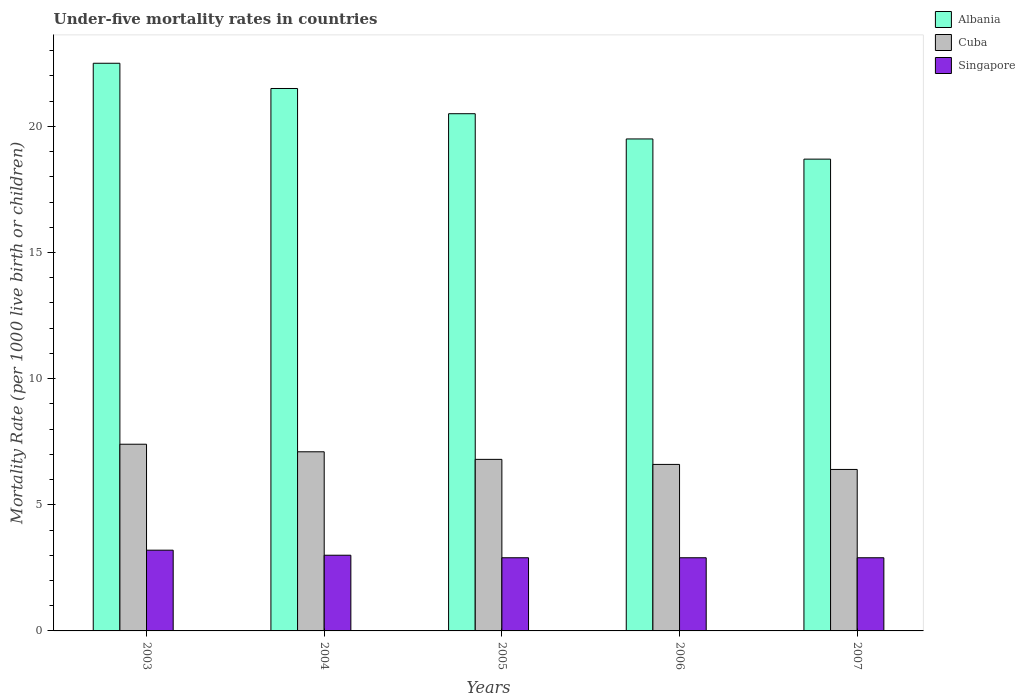How many groups of bars are there?
Your answer should be very brief. 5. Are the number of bars on each tick of the X-axis equal?
Provide a succinct answer. Yes. Across all years, what is the minimum under-five mortality rate in Singapore?
Offer a terse response. 2.9. In which year was the under-five mortality rate in Singapore maximum?
Your response must be concise. 2003. What is the total under-five mortality rate in Cuba in the graph?
Give a very brief answer. 34.3. What is the difference between the under-five mortality rate in Albania in 2003 and that in 2006?
Your answer should be very brief. 3. What is the difference between the under-five mortality rate in Singapore in 2007 and the under-five mortality rate in Albania in 2003?
Give a very brief answer. -19.6. What is the average under-five mortality rate in Cuba per year?
Offer a terse response. 6.86. In the year 2006, what is the difference between the under-five mortality rate in Singapore and under-five mortality rate in Albania?
Your response must be concise. -16.6. What is the ratio of the under-five mortality rate in Cuba in 2005 to that in 2006?
Provide a short and direct response. 1.03. Is the under-five mortality rate in Albania in 2003 less than that in 2006?
Keep it short and to the point. No. What is the difference between the highest and the second highest under-five mortality rate in Albania?
Keep it short and to the point. 1. What is the difference between the highest and the lowest under-five mortality rate in Albania?
Your answer should be compact. 3.8. Is the sum of the under-five mortality rate in Albania in 2004 and 2005 greater than the maximum under-five mortality rate in Cuba across all years?
Your answer should be compact. Yes. What does the 2nd bar from the left in 2007 represents?
Offer a terse response. Cuba. What does the 3rd bar from the right in 2003 represents?
Your answer should be very brief. Albania. How many years are there in the graph?
Ensure brevity in your answer.  5. What is the difference between two consecutive major ticks on the Y-axis?
Offer a terse response. 5. Does the graph contain grids?
Provide a short and direct response. No. Where does the legend appear in the graph?
Ensure brevity in your answer.  Top right. How many legend labels are there?
Offer a very short reply. 3. How are the legend labels stacked?
Make the answer very short. Vertical. What is the title of the graph?
Provide a short and direct response. Under-five mortality rates in countries. What is the label or title of the X-axis?
Give a very brief answer. Years. What is the label or title of the Y-axis?
Provide a succinct answer. Mortality Rate (per 1000 live birth or children). What is the Mortality Rate (per 1000 live birth or children) in Albania in 2004?
Your answer should be very brief. 21.5. What is the Mortality Rate (per 1000 live birth or children) of Cuba in 2004?
Offer a very short reply. 7.1. What is the Mortality Rate (per 1000 live birth or children) of Singapore in 2005?
Offer a very short reply. 2.9. What is the Mortality Rate (per 1000 live birth or children) in Cuba in 2006?
Your answer should be very brief. 6.6. What is the Mortality Rate (per 1000 live birth or children) in Albania in 2007?
Make the answer very short. 18.7. What is the Mortality Rate (per 1000 live birth or children) in Cuba in 2007?
Offer a very short reply. 6.4. Across all years, what is the maximum Mortality Rate (per 1000 live birth or children) of Albania?
Give a very brief answer. 22.5. Across all years, what is the maximum Mortality Rate (per 1000 live birth or children) of Cuba?
Offer a very short reply. 7.4. Across all years, what is the minimum Mortality Rate (per 1000 live birth or children) of Cuba?
Provide a succinct answer. 6.4. Across all years, what is the minimum Mortality Rate (per 1000 live birth or children) of Singapore?
Your answer should be compact. 2.9. What is the total Mortality Rate (per 1000 live birth or children) of Albania in the graph?
Offer a terse response. 102.7. What is the total Mortality Rate (per 1000 live birth or children) in Cuba in the graph?
Provide a succinct answer. 34.3. What is the difference between the Mortality Rate (per 1000 live birth or children) of Albania in 2003 and that in 2004?
Give a very brief answer. 1. What is the difference between the Mortality Rate (per 1000 live birth or children) in Cuba in 2003 and that in 2004?
Provide a short and direct response. 0.3. What is the difference between the Mortality Rate (per 1000 live birth or children) of Cuba in 2003 and that in 2005?
Ensure brevity in your answer.  0.6. What is the difference between the Mortality Rate (per 1000 live birth or children) of Singapore in 2003 and that in 2005?
Offer a very short reply. 0.3. What is the difference between the Mortality Rate (per 1000 live birth or children) in Cuba in 2003 and that in 2006?
Offer a very short reply. 0.8. What is the difference between the Mortality Rate (per 1000 live birth or children) of Singapore in 2003 and that in 2006?
Your answer should be very brief. 0.3. What is the difference between the Mortality Rate (per 1000 live birth or children) of Albania in 2003 and that in 2007?
Ensure brevity in your answer.  3.8. What is the difference between the Mortality Rate (per 1000 live birth or children) of Cuba in 2003 and that in 2007?
Your response must be concise. 1. What is the difference between the Mortality Rate (per 1000 live birth or children) of Albania in 2004 and that in 2005?
Your answer should be very brief. 1. What is the difference between the Mortality Rate (per 1000 live birth or children) in Singapore in 2004 and that in 2005?
Keep it short and to the point. 0.1. What is the difference between the Mortality Rate (per 1000 live birth or children) in Albania in 2004 and that in 2006?
Your answer should be compact. 2. What is the difference between the Mortality Rate (per 1000 live birth or children) in Cuba in 2004 and that in 2006?
Keep it short and to the point. 0.5. What is the difference between the Mortality Rate (per 1000 live birth or children) of Albania in 2004 and that in 2007?
Your answer should be very brief. 2.8. What is the difference between the Mortality Rate (per 1000 live birth or children) of Albania in 2005 and that in 2006?
Your answer should be very brief. 1. What is the difference between the Mortality Rate (per 1000 live birth or children) in Cuba in 2005 and that in 2006?
Ensure brevity in your answer.  0.2. What is the difference between the Mortality Rate (per 1000 live birth or children) of Singapore in 2005 and that in 2006?
Provide a short and direct response. 0. What is the difference between the Mortality Rate (per 1000 live birth or children) of Albania in 2006 and that in 2007?
Give a very brief answer. 0.8. What is the difference between the Mortality Rate (per 1000 live birth or children) in Cuba in 2006 and that in 2007?
Provide a succinct answer. 0.2. What is the difference between the Mortality Rate (per 1000 live birth or children) of Singapore in 2006 and that in 2007?
Your answer should be compact. 0. What is the difference between the Mortality Rate (per 1000 live birth or children) of Albania in 2003 and the Mortality Rate (per 1000 live birth or children) of Singapore in 2004?
Make the answer very short. 19.5. What is the difference between the Mortality Rate (per 1000 live birth or children) of Albania in 2003 and the Mortality Rate (per 1000 live birth or children) of Singapore in 2005?
Keep it short and to the point. 19.6. What is the difference between the Mortality Rate (per 1000 live birth or children) in Cuba in 2003 and the Mortality Rate (per 1000 live birth or children) in Singapore in 2005?
Make the answer very short. 4.5. What is the difference between the Mortality Rate (per 1000 live birth or children) in Albania in 2003 and the Mortality Rate (per 1000 live birth or children) in Singapore in 2006?
Give a very brief answer. 19.6. What is the difference between the Mortality Rate (per 1000 live birth or children) of Cuba in 2003 and the Mortality Rate (per 1000 live birth or children) of Singapore in 2006?
Your answer should be very brief. 4.5. What is the difference between the Mortality Rate (per 1000 live birth or children) in Albania in 2003 and the Mortality Rate (per 1000 live birth or children) in Singapore in 2007?
Your answer should be compact. 19.6. What is the difference between the Mortality Rate (per 1000 live birth or children) of Cuba in 2003 and the Mortality Rate (per 1000 live birth or children) of Singapore in 2007?
Your answer should be very brief. 4.5. What is the difference between the Mortality Rate (per 1000 live birth or children) in Albania in 2004 and the Mortality Rate (per 1000 live birth or children) in Cuba in 2005?
Provide a short and direct response. 14.7. What is the difference between the Mortality Rate (per 1000 live birth or children) in Albania in 2004 and the Mortality Rate (per 1000 live birth or children) in Singapore in 2005?
Provide a succinct answer. 18.6. What is the difference between the Mortality Rate (per 1000 live birth or children) in Albania in 2004 and the Mortality Rate (per 1000 live birth or children) in Cuba in 2006?
Provide a succinct answer. 14.9. What is the difference between the Mortality Rate (per 1000 live birth or children) in Albania in 2004 and the Mortality Rate (per 1000 live birth or children) in Singapore in 2006?
Provide a short and direct response. 18.6. What is the difference between the Mortality Rate (per 1000 live birth or children) of Cuba in 2004 and the Mortality Rate (per 1000 live birth or children) of Singapore in 2006?
Keep it short and to the point. 4.2. What is the difference between the Mortality Rate (per 1000 live birth or children) in Albania in 2004 and the Mortality Rate (per 1000 live birth or children) in Cuba in 2007?
Keep it short and to the point. 15.1. What is the difference between the Mortality Rate (per 1000 live birth or children) of Albania in 2004 and the Mortality Rate (per 1000 live birth or children) of Singapore in 2007?
Provide a short and direct response. 18.6. What is the difference between the Mortality Rate (per 1000 live birth or children) in Cuba in 2004 and the Mortality Rate (per 1000 live birth or children) in Singapore in 2007?
Offer a very short reply. 4.2. What is the difference between the Mortality Rate (per 1000 live birth or children) in Albania in 2005 and the Mortality Rate (per 1000 live birth or children) in Cuba in 2006?
Offer a very short reply. 13.9. What is the difference between the Mortality Rate (per 1000 live birth or children) of Albania in 2005 and the Mortality Rate (per 1000 live birth or children) of Cuba in 2007?
Your answer should be very brief. 14.1. What is the difference between the Mortality Rate (per 1000 live birth or children) of Albania in 2005 and the Mortality Rate (per 1000 live birth or children) of Singapore in 2007?
Provide a succinct answer. 17.6. What is the difference between the Mortality Rate (per 1000 live birth or children) in Cuba in 2006 and the Mortality Rate (per 1000 live birth or children) in Singapore in 2007?
Offer a terse response. 3.7. What is the average Mortality Rate (per 1000 live birth or children) of Albania per year?
Keep it short and to the point. 20.54. What is the average Mortality Rate (per 1000 live birth or children) of Cuba per year?
Make the answer very short. 6.86. What is the average Mortality Rate (per 1000 live birth or children) of Singapore per year?
Your response must be concise. 2.98. In the year 2003, what is the difference between the Mortality Rate (per 1000 live birth or children) in Albania and Mortality Rate (per 1000 live birth or children) in Cuba?
Provide a short and direct response. 15.1. In the year 2003, what is the difference between the Mortality Rate (per 1000 live birth or children) in Albania and Mortality Rate (per 1000 live birth or children) in Singapore?
Your answer should be very brief. 19.3. In the year 2003, what is the difference between the Mortality Rate (per 1000 live birth or children) of Cuba and Mortality Rate (per 1000 live birth or children) of Singapore?
Your answer should be compact. 4.2. In the year 2004, what is the difference between the Mortality Rate (per 1000 live birth or children) of Albania and Mortality Rate (per 1000 live birth or children) of Cuba?
Offer a terse response. 14.4. In the year 2005, what is the difference between the Mortality Rate (per 1000 live birth or children) of Albania and Mortality Rate (per 1000 live birth or children) of Singapore?
Make the answer very short. 17.6. In the year 2005, what is the difference between the Mortality Rate (per 1000 live birth or children) of Cuba and Mortality Rate (per 1000 live birth or children) of Singapore?
Your answer should be compact. 3.9. In the year 2006, what is the difference between the Mortality Rate (per 1000 live birth or children) in Albania and Mortality Rate (per 1000 live birth or children) in Cuba?
Offer a very short reply. 12.9. In the year 2007, what is the difference between the Mortality Rate (per 1000 live birth or children) in Albania and Mortality Rate (per 1000 live birth or children) in Singapore?
Provide a short and direct response. 15.8. What is the ratio of the Mortality Rate (per 1000 live birth or children) of Albania in 2003 to that in 2004?
Make the answer very short. 1.05. What is the ratio of the Mortality Rate (per 1000 live birth or children) in Cuba in 2003 to that in 2004?
Give a very brief answer. 1.04. What is the ratio of the Mortality Rate (per 1000 live birth or children) in Singapore in 2003 to that in 2004?
Ensure brevity in your answer.  1.07. What is the ratio of the Mortality Rate (per 1000 live birth or children) in Albania in 2003 to that in 2005?
Ensure brevity in your answer.  1.1. What is the ratio of the Mortality Rate (per 1000 live birth or children) in Cuba in 2003 to that in 2005?
Give a very brief answer. 1.09. What is the ratio of the Mortality Rate (per 1000 live birth or children) in Singapore in 2003 to that in 2005?
Offer a terse response. 1.1. What is the ratio of the Mortality Rate (per 1000 live birth or children) in Albania in 2003 to that in 2006?
Your response must be concise. 1.15. What is the ratio of the Mortality Rate (per 1000 live birth or children) of Cuba in 2003 to that in 2006?
Your answer should be compact. 1.12. What is the ratio of the Mortality Rate (per 1000 live birth or children) in Singapore in 2003 to that in 2006?
Make the answer very short. 1.1. What is the ratio of the Mortality Rate (per 1000 live birth or children) of Albania in 2003 to that in 2007?
Give a very brief answer. 1.2. What is the ratio of the Mortality Rate (per 1000 live birth or children) in Cuba in 2003 to that in 2007?
Make the answer very short. 1.16. What is the ratio of the Mortality Rate (per 1000 live birth or children) of Singapore in 2003 to that in 2007?
Give a very brief answer. 1.1. What is the ratio of the Mortality Rate (per 1000 live birth or children) of Albania in 2004 to that in 2005?
Keep it short and to the point. 1.05. What is the ratio of the Mortality Rate (per 1000 live birth or children) in Cuba in 2004 to that in 2005?
Your answer should be very brief. 1.04. What is the ratio of the Mortality Rate (per 1000 live birth or children) in Singapore in 2004 to that in 2005?
Your answer should be compact. 1.03. What is the ratio of the Mortality Rate (per 1000 live birth or children) of Albania in 2004 to that in 2006?
Your response must be concise. 1.1. What is the ratio of the Mortality Rate (per 1000 live birth or children) of Cuba in 2004 to that in 2006?
Offer a very short reply. 1.08. What is the ratio of the Mortality Rate (per 1000 live birth or children) of Singapore in 2004 to that in 2006?
Make the answer very short. 1.03. What is the ratio of the Mortality Rate (per 1000 live birth or children) of Albania in 2004 to that in 2007?
Ensure brevity in your answer.  1.15. What is the ratio of the Mortality Rate (per 1000 live birth or children) in Cuba in 2004 to that in 2007?
Your answer should be very brief. 1.11. What is the ratio of the Mortality Rate (per 1000 live birth or children) in Singapore in 2004 to that in 2007?
Offer a very short reply. 1.03. What is the ratio of the Mortality Rate (per 1000 live birth or children) in Albania in 2005 to that in 2006?
Provide a succinct answer. 1.05. What is the ratio of the Mortality Rate (per 1000 live birth or children) of Cuba in 2005 to that in 2006?
Make the answer very short. 1.03. What is the ratio of the Mortality Rate (per 1000 live birth or children) in Singapore in 2005 to that in 2006?
Offer a very short reply. 1. What is the ratio of the Mortality Rate (per 1000 live birth or children) of Albania in 2005 to that in 2007?
Offer a terse response. 1.1. What is the ratio of the Mortality Rate (per 1000 live birth or children) in Singapore in 2005 to that in 2007?
Ensure brevity in your answer.  1. What is the ratio of the Mortality Rate (per 1000 live birth or children) in Albania in 2006 to that in 2007?
Provide a succinct answer. 1.04. What is the ratio of the Mortality Rate (per 1000 live birth or children) of Cuba in 2006 to that in 2007?
Ensure brevity in your answer.  1.03. What is the ratio of the Mortality Rate (per 1000 live birth or children) of Singapore in 2006 to that in 2007?
Your response must be concise. 1. What is the difference between the highest and the second highest Mortality Rate (per 1000 live birth or children) of Cuba?
Your answer should be compact. 0.3. What is the difference between the highest and the lowest Mortality Rate (per 1000 live birth or children) in Cuba?
Keep it short and to the point. 1. What is the difference between the highest and the lowest Mortality Rate (per 1000 live birth or children) of Singapore?
Your response must be concise. 0.3. 